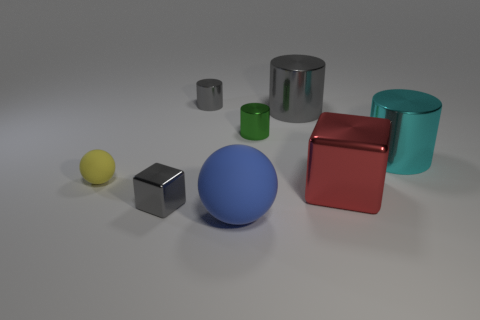Add 2 small spheres. How many objects exist? 10 Subtract 2 blocks. How many blocks are left? 0 Subtract all cyan blocks. How many yellow spheres are left? 1 Subtract all red blocks. Subtract all tiny green metal things. How many objects are left? 6 Add 8 big blue objects. How many big blue objects are left? 9 Add 4 shiny cubes. How many shiny cubes exist? 6 Subtract all red cubes. How many cubes are left? 1 Subtract 0 blue cylinders. How many objects are left? 8 Subtract all spheres. How many objects are left? 6 Subtract all blue blocks. Subtract all cyan cylinders. How many blocks are left? 2 